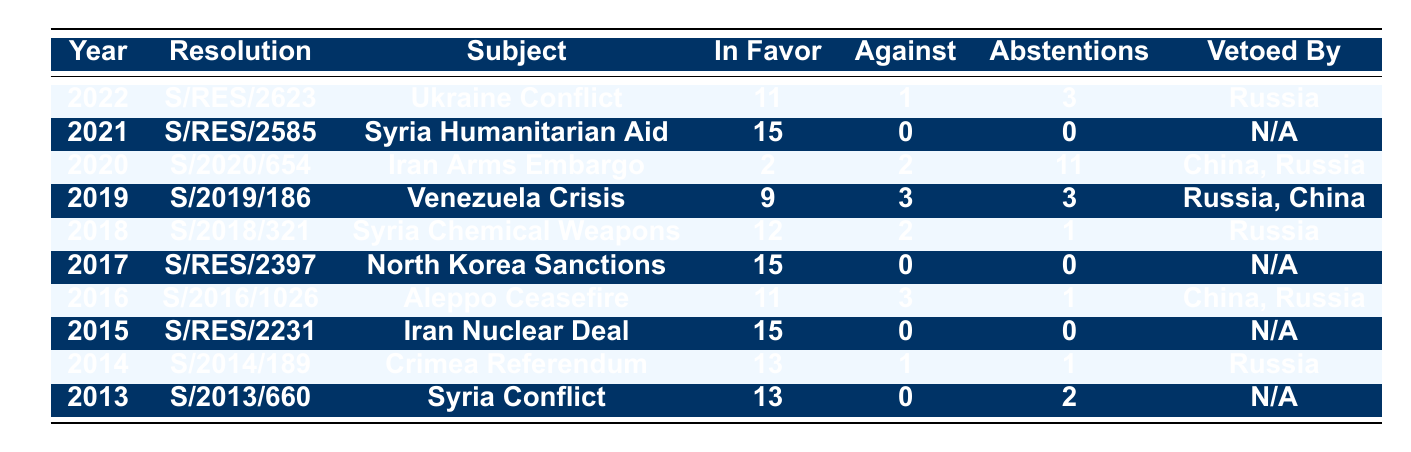What year was the resolution on the Ukraine Conflict passed? The table lists the resolution labeled as "S/RES/2623" under the year 2022.
Answer: 2022 How many resolutions received a unanimous vote (15 in favor, 0 against)? The table shows two resolutions that had a unanimous vote: "S/RES/2585" in 2021 and "S/RES/2231" in 2015, where both had 15 votes in favor and 0 against.
Answer: 2 What is the total number of abstentions recorded across all resolutions listed? The table lists the abstentions for each resolution. Adding them yields: 3 + 0 + 11 + 3 + 1 + 0 + 1 + 0 + 1 + 2 = 22 abstentions total.
Answer: 22 Was there any resolution from 2019 that was vetoed? In the 2019 resolution labeled "S/2019/186," it indicates it was vetoed by Russia and China, so yes, it was vetoed.
Answer: Yes Which resolution had the highest number of abstentions and how many? By reviewing the abstention column in the table, "S/2020/654" had the highest abstentions with a count of 11.
Answer: S/2020/654, 11 What percentage of resolutions listed from 2013 to 2022 passed with more than 10 votes in favor? Analyzing the "In Favor" column from 2013-2022, the resolutions with over 10 votes in favor are S/RES/2623 (11), S/RES/2585 (15), S/2018/321 (12), S/RES/2397 (15), S/2016/1026 (11), S/RES/2231 (15) totaling 6 out of 10, giving a percentage of (6/10)*100 = 60%.
Answer: 60% How many resolutions regarding Syria are listed, and what are their years? The table records two resolutions concerning Syria: "S/RES/2585" from 2021 and "S/2018/321" from 2018, resulting in a total of 2.
Answer: 2, 2021 and 2018 If Russia had vetoed a resolution, how many votes in favor were there in those instances? Looking at the resolutions vetoed by Russia - "S/RES/2623" had 11 votes in favor and "S/2014/189" had 13 votes in favor. Adding these gives: 11 + 13 = 24 votes in favor total.
Answer: 24 